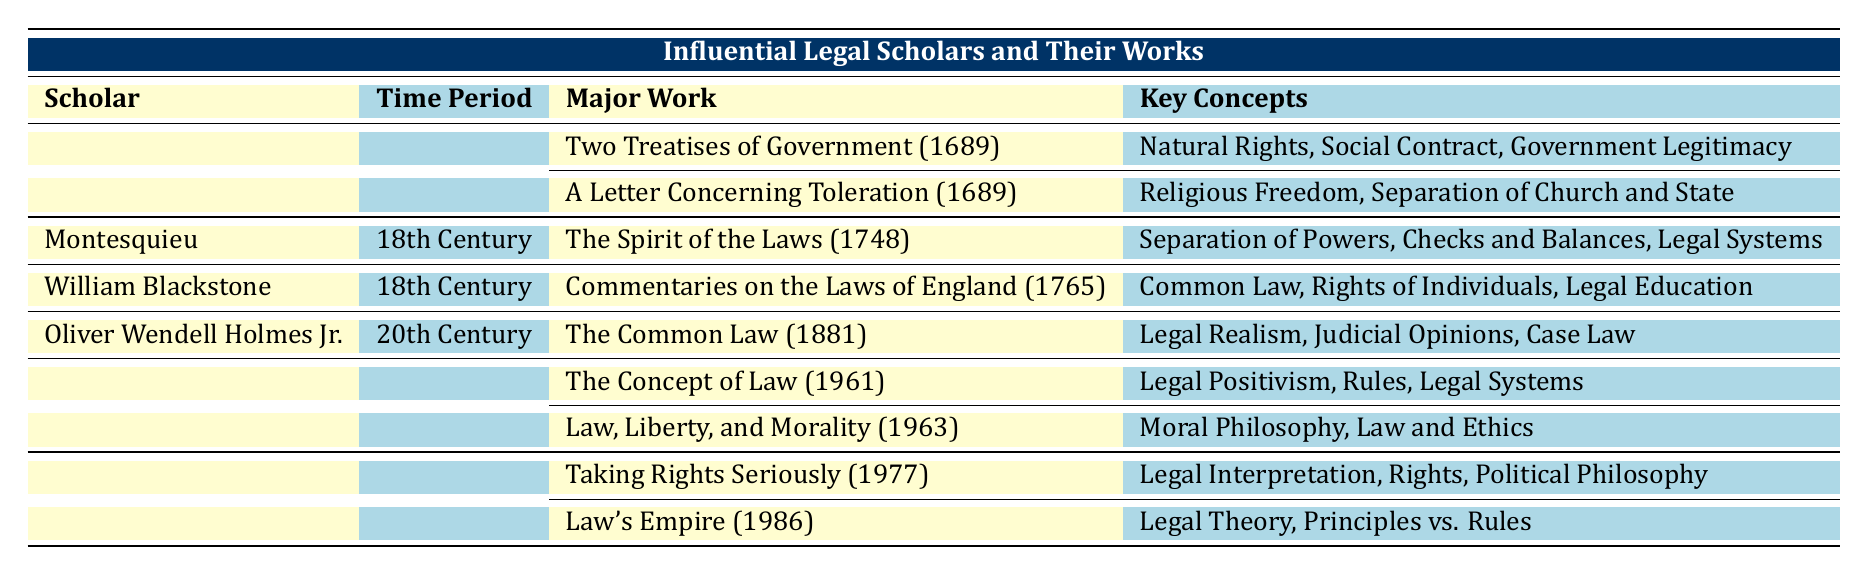What time period did John Locke belong to? The table clearly states that John Locke is associated with the 17th Century in the 'Time Period' column.
Answer: 17th Century Which scholar wrote "The Spirit of the Laws"? By examining the table, we can find that "The Spirit of the Laws" is listed under Montesquieu in the 'Major Work' column.
Answer: Montesquieu How many major works did H.L.A. Hart publish according to the table? The table shows two major works listed under H.L.A. Hart: "The Concept of Law" and "Law, Liberty, and Morality." Thus, he published two major works.
Answer: 2 True or False: William Blackstone wrote "Taking Rights Seriously." By looking at the 'Major Works' section, it shows that "Taking Rights Seriously" is attributed to Ronald Dworkin, not William Blackstone. Therefore, the statement is false.
Answer: False Which scholar's works focused on the concept of 'Legal Realism'? The table indicates that Oliver Wendell Holmes Jr. authored "The Common Law," which encompasses the concept of 'Legal Realism,' making it clear that this scholar is the one in question.
Answer: Oliver Wendell Holmes Jr What are the key concepts associated with Montesquieu's major work? To find the key concepts, we look under Montesquieu's entry, where "The Spirit of the Laws" is listed with the key concepts: Separation of Powers, Checks and Balances, and Legal Systems.
Answer: Separation of Powers, Checks and Balances, Legal Systems What is the total number of key concepts identified in the works of Ronald Dworkin? Ronald Dworkin has two major works: "Taking Rights Seriously" with three concepts, and "Law's Empire" with two concepts, totaling five concepts. This is calculated as 3 + 2 = 5.
Answer: 5 Which century did H.L.A. Hart's works belong to? By referring to the 'Time Period' column, we see that H.L.A. Hart is associated with the 20th Century.
Answer: 20th Century What are the key concepts associated with H.L.A. Hart's book "The Concept of Law"? The table lists "The Concept of Law" under H.L.A. Hart, stating its key concepts: Legal Positivism, Rules, and Legal Systems.
Answer: Legal Positivism, Rules, Legal Systems 